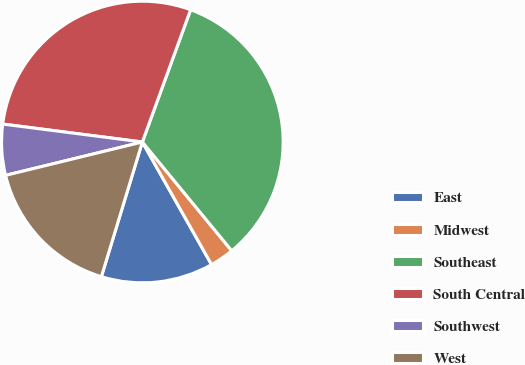<chart> <loc_0><loc_0><loc_500><loc_500><pie_chart><fcel>East<fcel>Midwest<fcel>Southeast<fcel>South Central<fcel>Southwest<fcel>West<nl><fcel>12.88%<fcel>2.77%<fcel>33.48%<fcel>28.53%<fcel>5.84%<fcel>16.49%<nl></chart> 